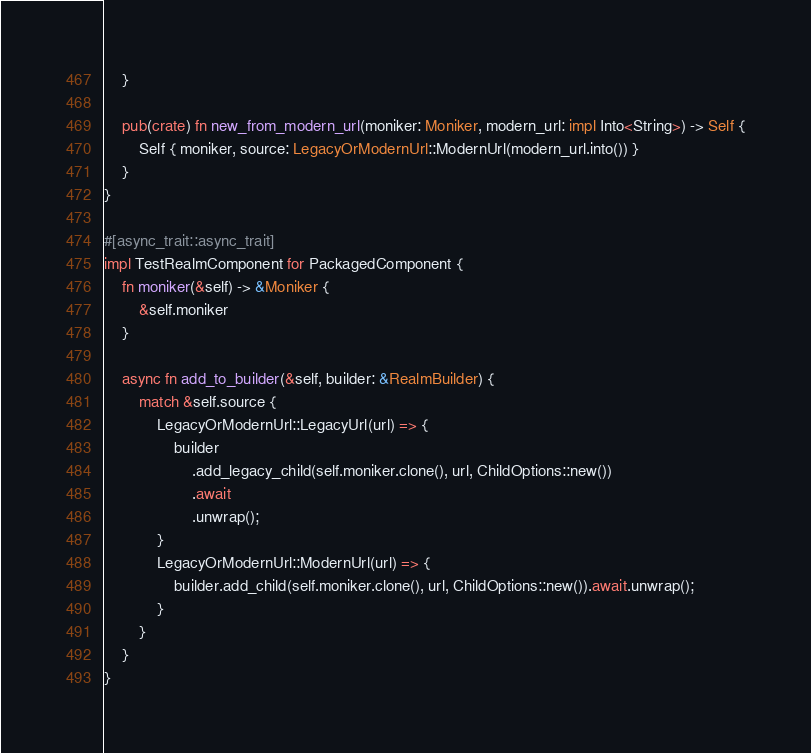Convert code to text. <code><loc_0><loc_0><loc_500><loc_500><_Rust_>    }

    pub(crate) fn new_from_modern_url(moniker: Moniker, modern_url: impl Into<String>) -> Self {
        Self { moniker, source: LegacyOrModernUrl::ModernUrl(modern_url.into()) }
    }
}

#[async_trait::async_trait]
impl TestRealmComponent for PackagedComponent {
    fn moniker(&self) -> &Moniker {
        &self.moniker
    }

    async fn add_to_builder(&self, builder: &RealmBuilder) {
        match &self.source {
            LegacyOrModernUrl::LegacyUrl(url) => {
                builder
                    .add_legacy_child(self.moniker.clone(), url, ChildOptions::new())
                    .await
                    .unwrap();
            }
            LegacyOrModernUrl::ModernUrl(url) => {
                builder.add_child(self.moniker.clone(), url, ChildOptions::new()).await.unwrap();
            }
        }
    }
}
</code> 